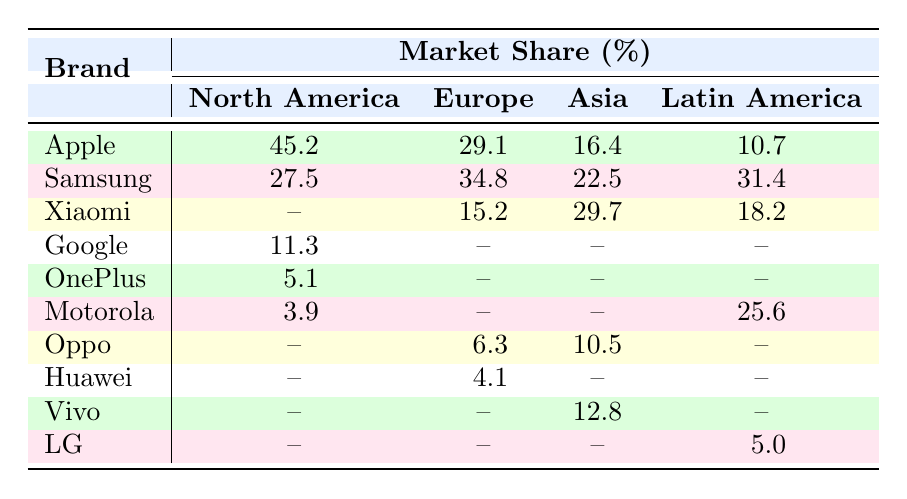What is the market share of Apple in North America? According to the table, the market share of Apple in North America is specifically listed as 45.2%.
Answer: 45.2% Which brand has the highest market share in Europe? The table indicates that Samsung has the highest market share in Europe, which is 34.8%.
Answer: Samsung What is the market share difference between Samsung in Latin America and Motorola in Latin America? From the table, Samsung has a market share of 31.4% and Motorola has 25.6% in Latin America. The difference is calculated as 31.4% - 25.6% = 5.8%.
Answer: 5.8% Does Xiaomi have a presence in North America according to the table? The table shows there is no market share listed for Xiaomi in North America, which indicates they do not hold a presence there based on this data.
Answer: No What is the average market share for Apple across all regions? The table shows Apple’s market shares as follows: North America (45.2%), Europe (29.1%), Asia (16.4%), and Latin America (10.7%). To find the average, we sum these values: 45.2 + 29.1 + 16.4 + 10.7 = 101.4. There are 4 regions, so we divide by 4: 101.4 / 4 = 25.35%.
Answer: 25.35% Which brand has the lowest market share globally, and what is that percentage? By reviewing the market shares, OnePlus and Huawei both have notable low percentages. OnePlus is at 5.1% in North America, while Huawei has no presence in other regions listed. Considering that Huawei has 0% in most, OnePlus has the lowest at 5.1%.
Answer: OnePlus, 5.1% Is it true that Samsung has a higher market share in Europe than in Asia? The table indicates Samsung has a market share of 34.8% in Europe and 22.5% in Asia, confirming that Samsung's share is indeed higher in Europe than in Asia.
Answer: Yes 